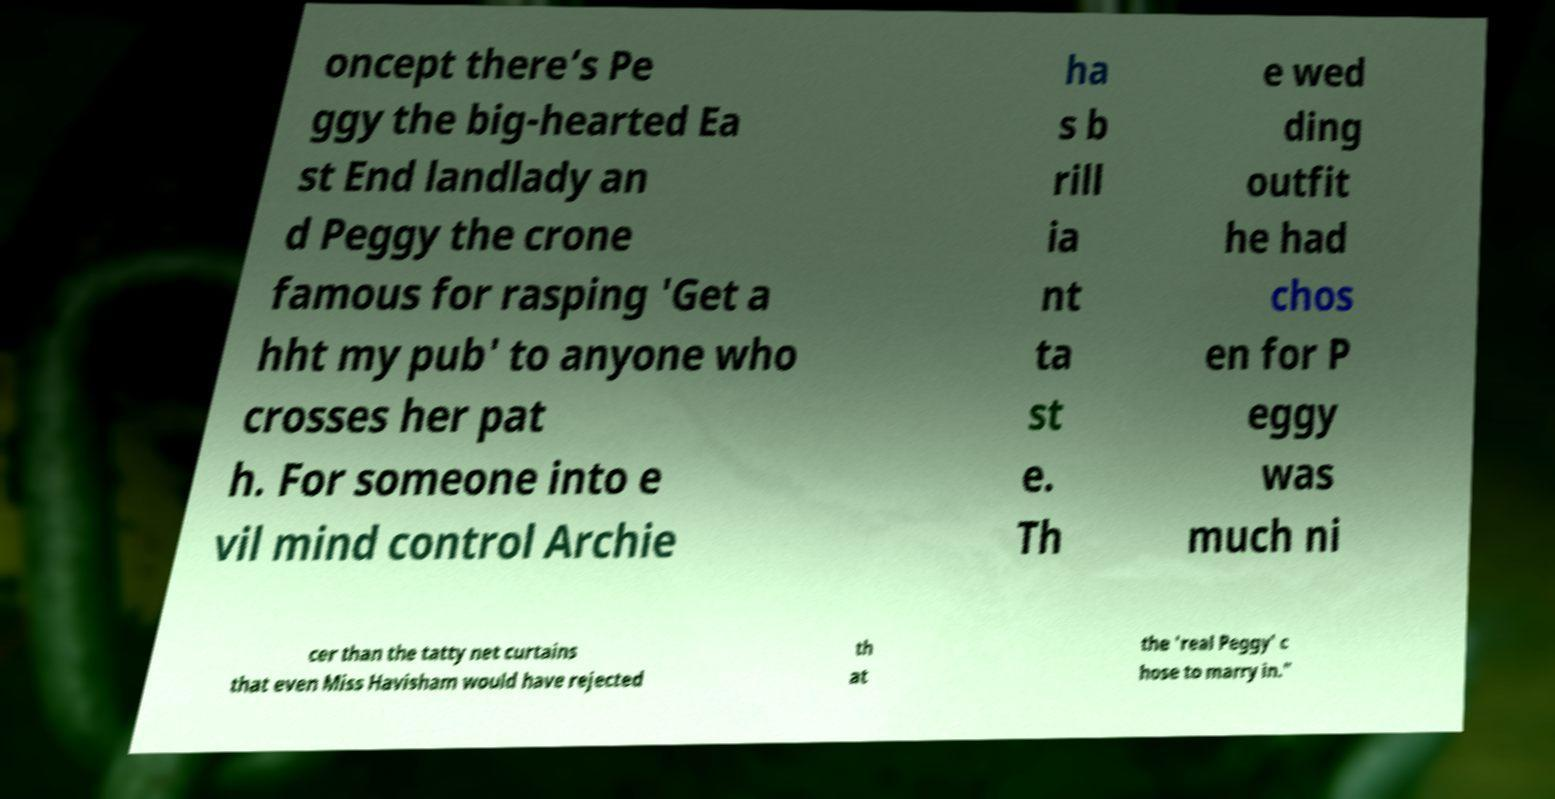Could you assist in decoding the text presented in this image and type it out clearly? oncept there’s Pe ggy the big-hearted Ea st End landlady an d Peggy the crone famous for rasping 'Get a hht my pub' to anyone who crosses her pat h. For someone into e vil mind control Archie ha s b rill ia nt ta st e. Th e wed ding outfit he had chos en for P eggy was much ni cer than the tatty net curtains that even Miss Havisham would have rejected th at the 'real Peggy' c hose to marry in." 